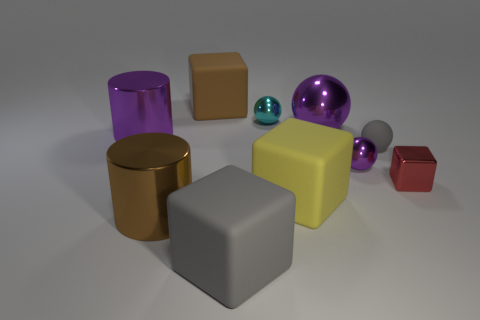How many objects are either objects that are in front of the large brown metallic object or small things?
Provide a short and direct response. 5. There is a brown thing to the left of the large brown rubber cube; what is its size?
Provide a succinct answer. Large. Are there fewer small brown matte balls than small purple things?
Ensure brevity in your answer.  Yes. Are the tiny sphere in front of the small gray matte object and the gray object that is behind the red metallic cube made of the same material?
Your answer should be very brief. No. The large brown object in front of the small gray rubber ball behind the gray matte object that is left of the small cyan thing is what shape?
Your response must be concise. Cylinder. What number of tiny purple spheres have the same material as the big yellow thing?
Keep it short and to the point. 0. There is a purple ball that is behind the tiny matte ball; what number of rubber spheres are in front of it?
Provide a succinct answer. 1. There is a big shiny thing that is left of the brown cylinder; does it have the same color as the big metal object in front of the small purple shiny sphere?
Your answer should be compact. No. There is a matte object that is both to the left of the tiny cyan metallic sphere and behind the tiny purple shiny sphere; what shape is it?
Your response must be concise. Cube. Is there a big purple rubber thing that has the same shape as the yellow rubber thing?
Make the answer very short. No. 